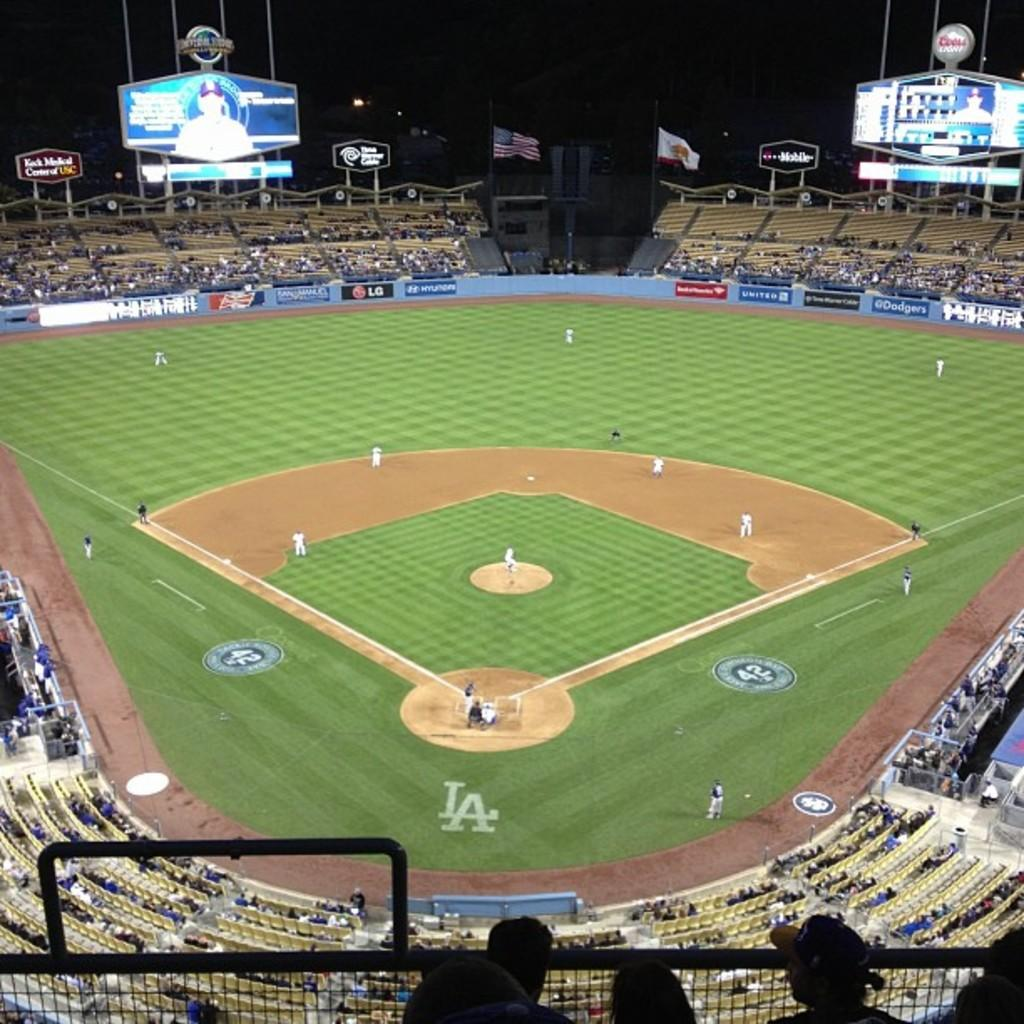<image>
Share a concise interpretation of the image provided. A view of a baseball field with the letters LA behind home plate. 